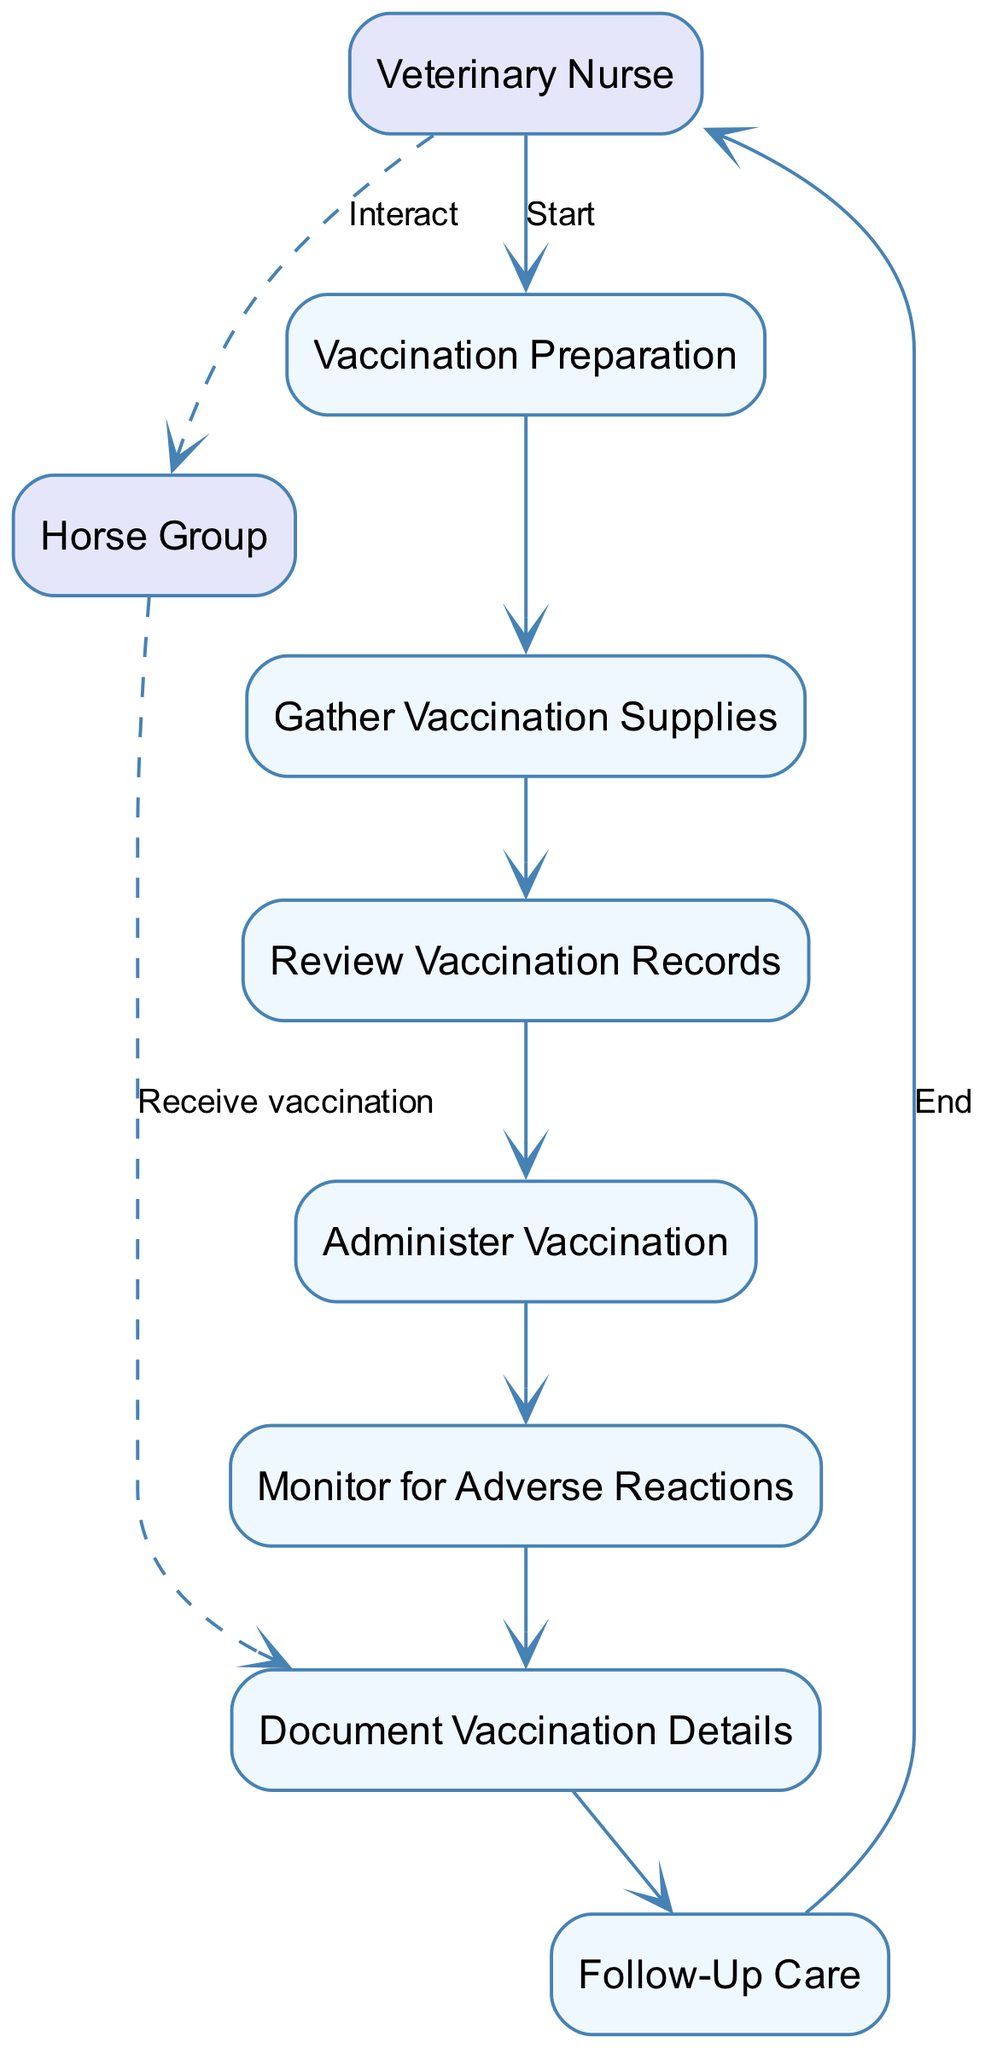What is the first process in the diagram? The first process connected to the Veterinary Nurse is "Vaccination Preparation." This can be observed from the directed edge that connects the nurse to the first process.
Answer: Vaccination Preparation How many processes are present in the diagram? By counting all the unique processes listed in the elements, we find there are eight distinct processes.
Answer: Eight What is the last process before the follow-up care? The last process that occurs before the "Follow-Up Care" is "Document Vaccination Details." Looking at the flow of the diagram, it connects directly to "Follow-Up Care."
Answer: Document Vaccination Details What type of relationship exists between the Veterinary Nurse and the Horse Group? The relationship is represented by a dashed edge, indicating an interaction. This is a visual cue that shows that the Veterinary Nurse interacts with the Horse Group at certain points in the workflow.
Answer: Interact Which process involves monitoring the horses? "Monitor for Adverse Reactions" is the process specifically focused on monitoring the horses after they have received the vaccination. This can be identified by the direct connection from the vaccination process to this monitoring step.
Answer: Monitor for Adverse Reactions How does the Veterinary Nurse end the workflow? The workflow ends with a directed edge going back to the Veterinary Nurse from the last process, denoting the completion of the overall vaccination task. It shows that after the last process, the nurse is the one finalizing the task.
Answer: End Which process comes after "Gather Vaccination Supplies"? "Review Vaccination Records" directly follows "Gather Vaccination Supplies," as the arrows connecting the two indicate the order of operations in the workflow.
Answer: Review Vaccination Records What does the Horse Group do after receiving vaccination? The Horse Group does not have a subsequent process listed in the diagram; it merely receives the vaccination, indicated by the dashed edge from the Horse Group to the vaccination process. Thus, there's no additional action after receiving vaccination shown in this sequence.
Answer: Receive vaccination 